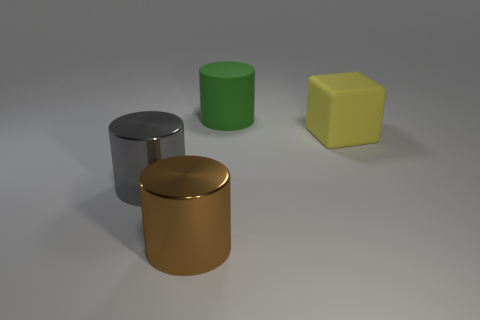Add 2 big yellow blocks. How many objects exist? 6 Subtract all cylinders. How many objects are left? 1 Add 2 large green cylinders. How many large green cylinders are left? 3 Add 3 tiny red metallic cylinders. How many tiny red metallic cylinders exist? 3 Subtract 1 gray cylinders. How many objects are left? 3 Subtract all red blocks. Subtract all big cubes. How many objects are left? 3 